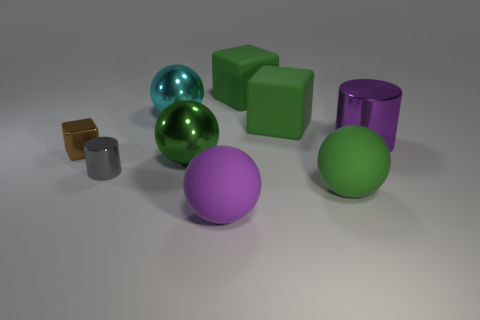Subtract all cyan spheres. How many spheres are left? 3 Subtract all red balls. Subtract all yellow cubes. How many balls are left? 4 Add 1 purple metallic spheres. How many objects exist? 10 Subtract all balls. How many objects are left? 5 Add 1 big green rubber balls. How many big green rubber balls are left? 2 Add 5 large purple matte objects. How many large purple matte objects exist? 6 Subtract 0 red balls. How many objects are left? 9 Subtract all metal cubes. Subtract all tiny gray objects. How many objects are left? 7 